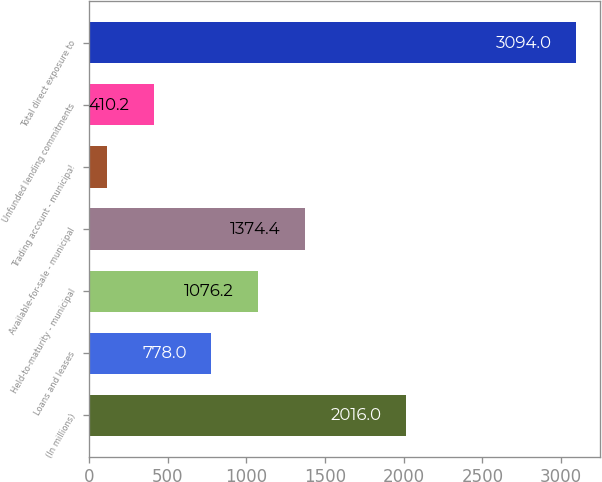Convert chart. <chart><loc_0><loc_0><loc_500><loc_500><bar_chart><fcel>(In millions)<fcel>Loans and leases<fcel>Held-to-maturity - municipal<fcel>Available-for-sale - municipal<fcel>Trading account - municipal<fcel>Unfunded lending commitments<fcel>Total direct exposure to<nl><fcel>2016<fcel>778<fcel>1076.2<fcel>1374.4<fcel>112<fcel>410.2<fcel>3094<nl></chart> 